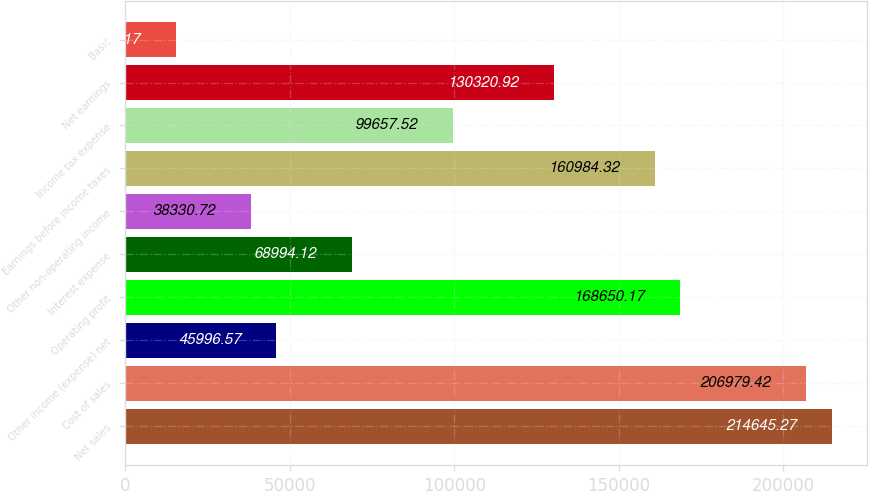<chart> <loc_0><loc_0><loc_500><loc_500><bar_chart><fcel>Net sales<fcel>Cost of sales<fcel>Other income (expense) net<fcel>Operating profit<fcel>Interest expense<fcel>Other non-operating income<fcel>Earnings before income taxes<fcel>Income tax expense<fcel>Net earnings<fcel>Basic<nl><fcel>214645<fcel>206979<fcel>45996.6<fcel>168650<fcel>68994.1<fcel>38330.7<fcel>160984<fcel>99657.5<fcel>130321<fcel>15333.2<nl></chart> 